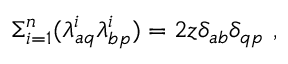Convert formula to latex. <formula><loc_0><loc_0><loc_500><loc_500>\Sigma _ { i = 1 } ^ { n } ( \lambda _ { a q } ^ { i } \lambda _ { b p } ^ { i } ) = 2 z \delta _ { a b } \delta _ { q p } \ ,</formula> 